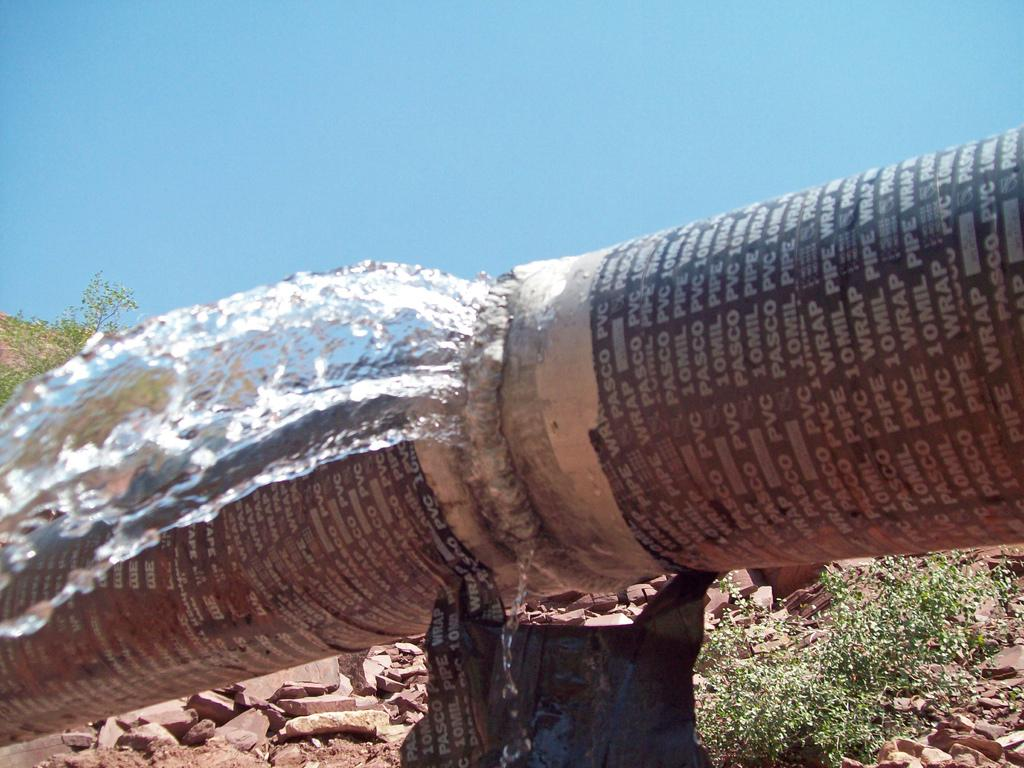What is the main object in the image? There is a large pipe in the image. What is happening to the pipe? Water is leaking from the pipe. What type of natural elements can be seen in the image? There are stones and plants visible in the image. What can be seen in the background of the image? The sky is visible in the background of the image. What type of office furniture can be seen in the image? There is no office furniture present in the image; it features a large pipe with leaking water, stones, plants, and a visible sky. What is the iron being used for in the image? There is no iron present in the image. 